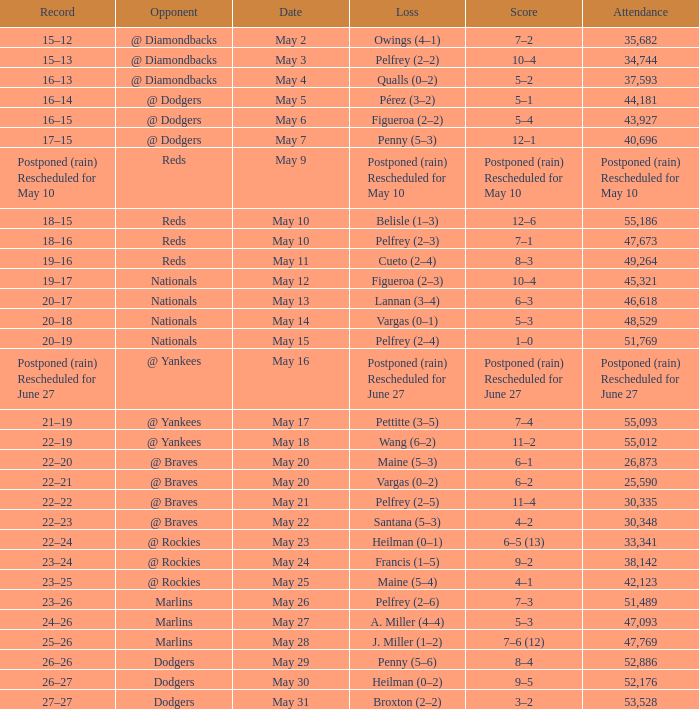Attendance of 30,335 had what record? 22–22. 